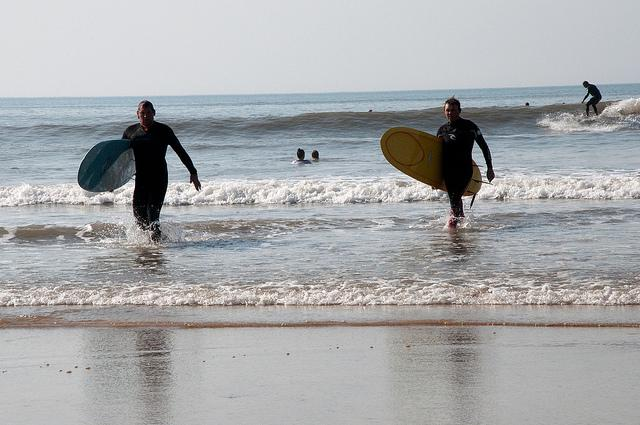What color is the surfboard held by the man walking up the beach on the right? Please explain your reasoning. yellow. It's the color of a banana 